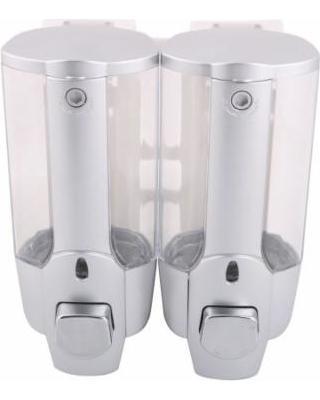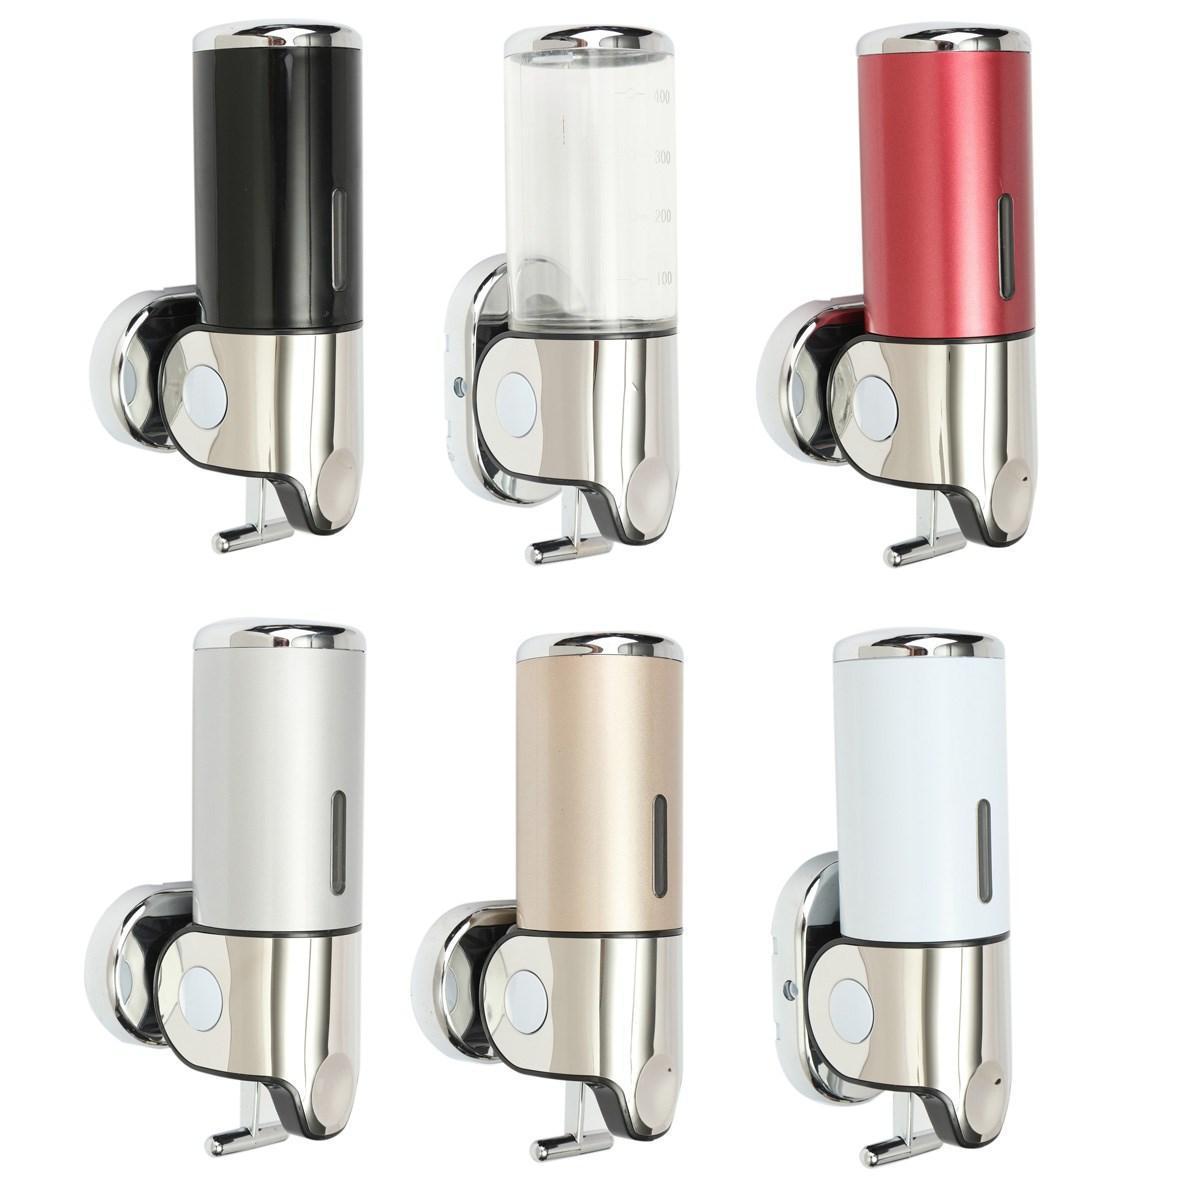The first image is the image on the left, the second image is the image on the right. Considering the images on both sides, is "There are at least six dispensers." valid? Answer yes or no. Yes. The first image is the image on the left, the second image is the image on the right. Given the left and right images, does the statement "In a group of three shower soap dispensers, one contains green liquid soap." hold true? Answer yes or no. No. 